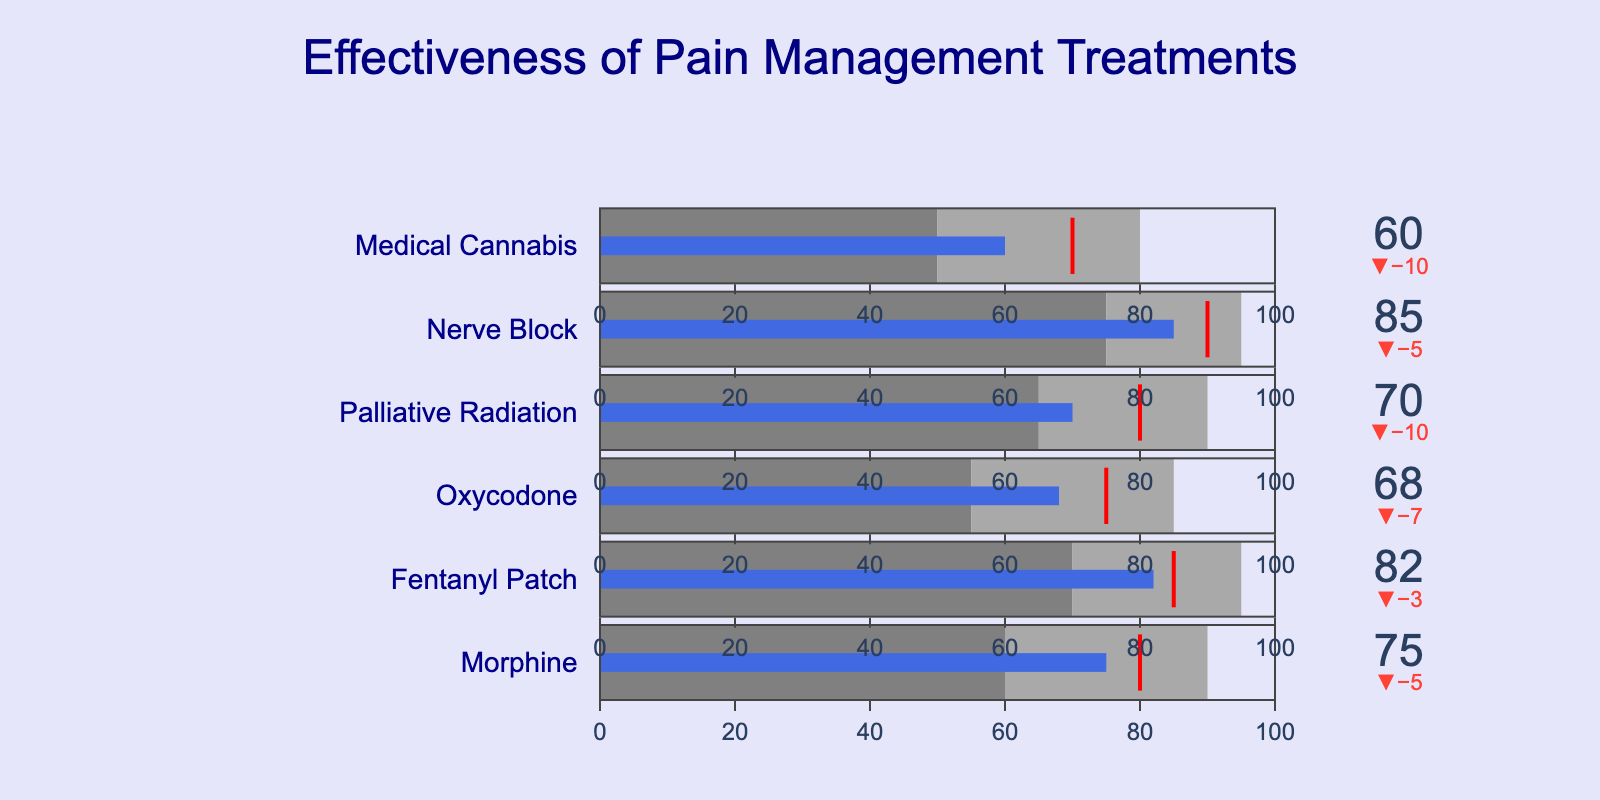What is the title of the figure? The title is usually displayed at the top of the figure and is written in a larger font size. Here, it reads "Effectiveness of Pain Management Treatments."
Answer: Effectiveness of Pain Management Treatments Which treatments have an actual effectiveness value that meets or exceeds the target? To determine this, we need to compare the 'Actual' values with the 'Target' values for each treatment. Morphine (75 < 80), Fentanyl Patch (82 < 85), Oxycodone (68 < 75), Palliative Radiation (70 < 80), Nerve Block (85 < 90), Medical Cannabis (60 < 70). None of the treatments meet or exceed the target.
Answer: None Which treatment has the highest actual effectiveness? Look at the 'Actual' effectiveness values for all treatments to find the maximum value. The values are: Morphine (75), Fentanyl Patch (82), Oxycodone (68), Palliative Radiation (70), Nerve Block (85), Medical Cannabis (60). The highest value is 85 for Nerve Block.
Answer: Nerve Block How much higher is the actual effectiveness of Medical Cannabis compared to its 'Poor' threshold? The 'Actual' value for Medical Cannabis is 60, and the 'Poor' threshold is 50. To get the difference, subtract the 'Poor' value from the 'Actual' (60 - 50).
Answer: 10 Which treatments fall into the 'Excellent' effectiveness category? The 'Excellent' category thresholds are: Morphine (90), Fentanyl Patch (95), Oxycodone (85), Palliative Radiation (90), Nerve Block (95), Medical Cannabis (80). Compare the 'Actual' values: Morphine (75), Fentanyl Patch (82), Oxycodone (68), Palliative Radiation (70), Nerve Block (85), Medical Cannabis (60). None of the treatments fall into the 'Excellent' category.
Answer: None Which treatment has the smallest difference between actual and target effectiveness? To answer this, calculate the absolute difference between 'Actual' and 'Target' for each treatment and identify the smallest difference. The differences are: Morphine (80 - 75 = 5), Fentanyl Patch (85 - 82 = 3), Oxycodone (75 - 68 = 7), Palliative Radiation (80 - 70 = 10), Nerve Block (90 - 85 = 5), Medical Cannabis (70 - 60 = 10). The smallest difference is for the Fentanyl Patch (3).
Answer: Fentanyl Patch Which treatment's actual effectiveness is within the 'Satisfactory' range? Check each treatment's 'Actual' value against its 'Satisfactory' thresholds: Morphine (60 - 90), Fentanyl Patch (70 - 95), Oxycodone (55 - 85), Palliative Radiation (65 - 90), Nerve Block (75 - 95), Medical Cannabis (50 - 80). All treatments have their 'Actual' values within these ranges.
Answer: All What's the overall range of actual effectiveness scores across all treatments? Identify the minimum and maximum 'Actual' values among all treatments. The values are: Morphine (75), Fentanyl Patch (82), Oxycodone (68), Palliative Radiation (70), Nerve Block (85), Medical Cannabis (60). The range is from the minimum (60) to the maximum (85), so 85 - 60.
Answer: 25 